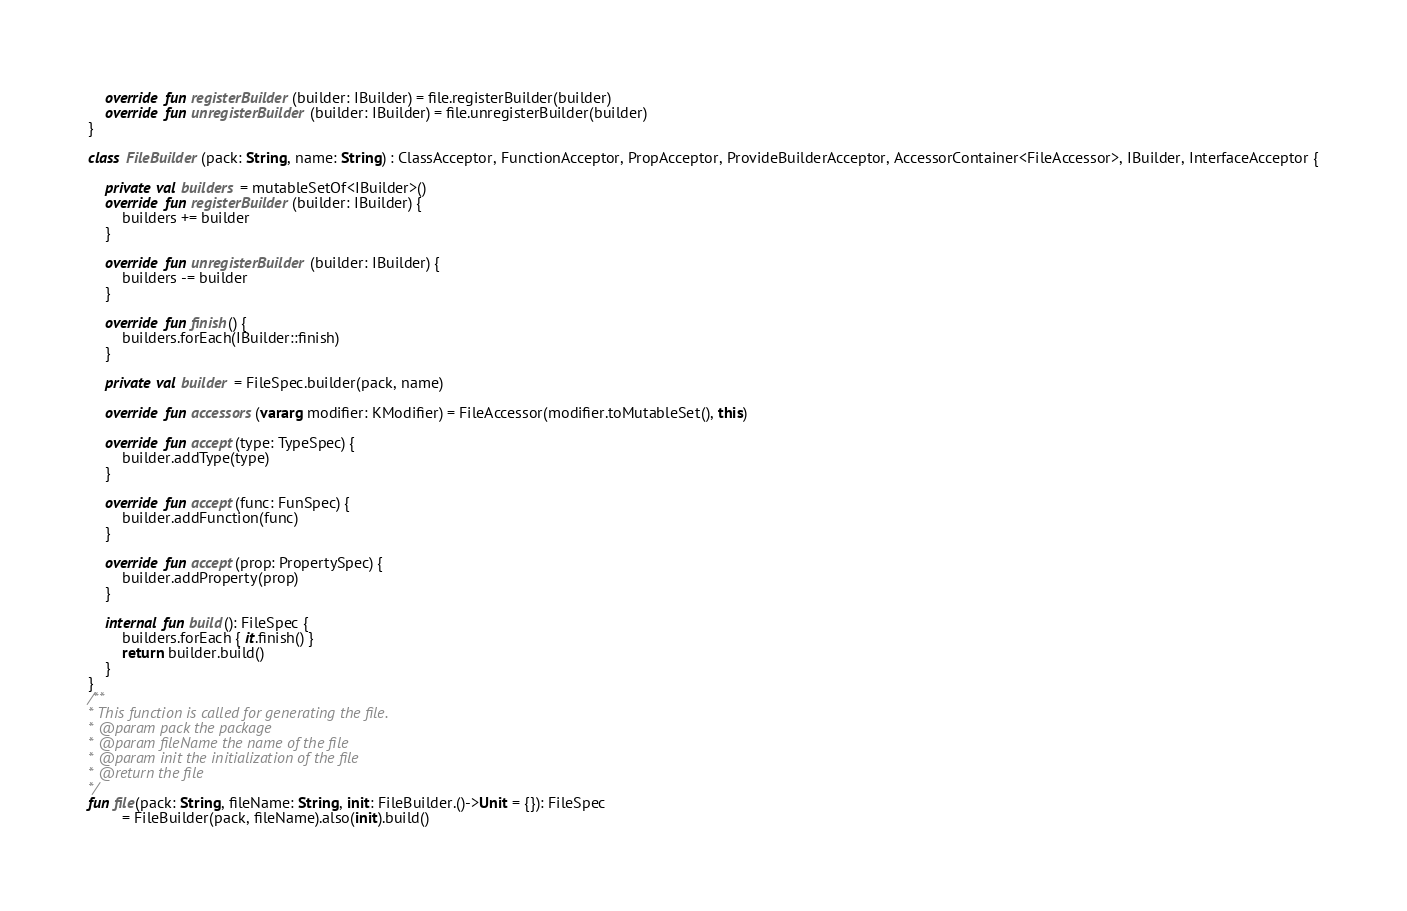<code> <loc_0><loc_0><loc_500><loc_500><_Kotlin_>    override fun registerBuilder(builder: IBuilder) = file.registerBuilder(builder)
    override fun unregisterBuilder(builder: IBuilder) = file.unregisterBuilder(builder)
}

class FileBuilder(pack: String, name: String) : ClassAcceptor, FunctionAcceptor, PropAcceptor, ProvideBuilderAcceptor, AccessorContainer<FileAccessor>, IBuilder, InterfaceAcceptor {

    private val builders = mutableSetOf<IBuilder>()
    override fun registerBuilder(builder: IBuilder) {
        builders += builder
    }

    override fun unregisterBuilder(builder: IBuilder) {
        builders -= builder
    }

    override fun finish() {
        builders.forEach(IBuilder::finish)
    }

    private val builder = FileSpec.builder(pack, name)

    override fun accessors(vararg modifier: KModifier) = FileAccessor(modifier.toMutableSet(), this)

    override fun accept(type: TypeSpec) {
        builder.addType(type)
    }

    override fun accept(func: FunSpec) {
        builder.addFunction(func)
    }

    override fun accept(prop: PropertySpec) {
        builder.addProperty(prop)
    }

    internal fun build(): FileSpec {
        builders.forEach { it.finish() }
        return builder.build()
    }
}
/**
* This function is called for generating the file.
* @param pack the package
* @param fileName the name of the file
* @param init the initialization of the file
* @return the file
*/
fun file(pack: String, fileName: String, init: FileBuilder.()->Unit = {}): FileSpec
        = FileBuilder(pack, fileName).also(init).build()</code> 